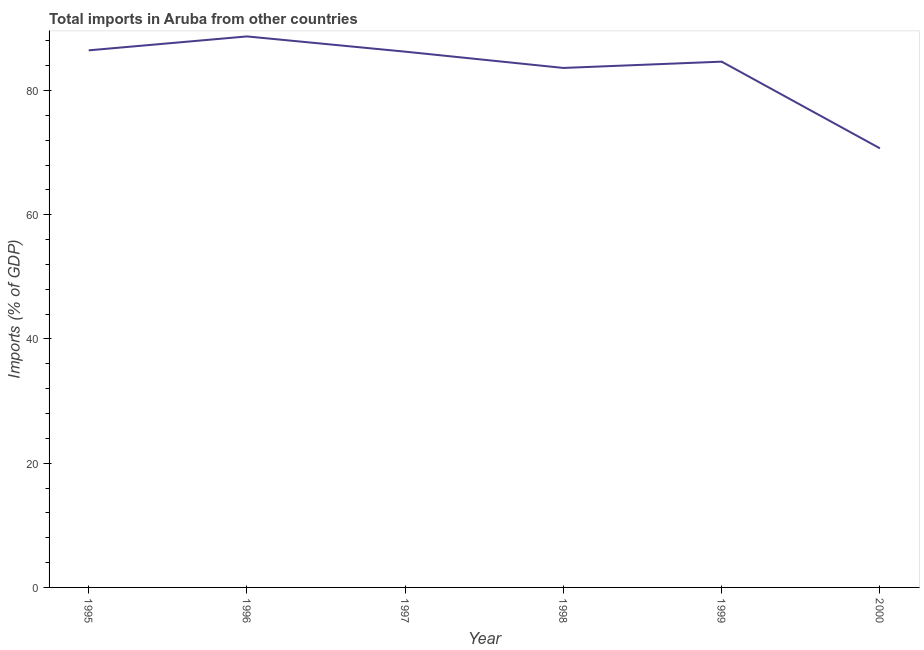What is the total imports in 2000?
Offer a terse response. 70.69. Across all years, what is the maximum total imports?
Offer a very short reply. 88.7. Across all years, what is the minimum total imports?
Your response must be concise. 70.69. In which year was the total imports maximum?
Provide a succinct answer. 1996. In which year was the total imports minimum?
Give a very brief answer. 2000. What is the sum of the total imports?
Provide a short and direct response. 500.38. What is the difference between the total imports in 1995 and 1998?
Offer a terse response. 2.83. What is the average total imports per year?
Ensure brevity in your answer.  83.4. What is the median total imports?
Your response must be concise. 85.45. What is the ratio of the total imports in 1996 to that in 2000?
Ensure brevity in your answer.  1.25. Is the difference between the total imports in 1998 and 1999 greater than the difference between any two years?
Your answer should be compact. No. What is the difference between the highest and the second highest total imports?
Give a very brief answer. 2.24. Is the sum of the total imports in 1997 and 2000 greater than the maximum total imports across all years?
Your answer should be compact. Yes. What is the difference between the highest and the lowest total imports?
Ensure brevity in your answer.  18.02. How many years are there in the graph?
Keep it short and to the point. 6. Does the graph contain grids?
Offer a terse response. No. What is the title of the graph?
Give a very brief answer. Total imports in Aruba from other countries. What is the label or title of the X-axis?
Your answer should be very brief. Year. What is the label or title of the Y-axis?
Make the answer very short. Imports (% of GDP). What is the Imports (% of GDP) of 1995?
Your answer should be compact. 86.46. What is the Imports (% of GDP) in 1996?
Offer a terse response. 88.7. What is the Imports (% of GDP) of 1997?
Ensure brevity in your answer.  86.25. What is the Imports (% of GDP) of 1998?
Your answer should be compact. 83.63. What is the Imports (% of GDP) in 1999?
Offer a terse response. 84.64. What is the Imports (% of GDP) in 2000?
Provide a succinct answer. 70.69. What is the difference between the Imports (% of GDP) in 1995 and 1996?
Ensure brevity in your answer.  -2.24. What is the difference between the Imports (% of GDP) in 1995 and 1997?
Ensure brevity in your answer.  0.21. What is the difference between the Imports (% of GDP) in 1995 and 1998?
Keep it short and to the point. 2.83. What is the difference between the Imports (% of GDP) in 1995 and 1999?
Your answer should be compact. 1.82. What is the difference between the Imports (% of GDP) in 1995 and 2000?
Make the answer very short. 15.78. What is the difference between the Imports (% of GDP) in 1996 and 1997?
Your answer should be compact. 2.45. What is the difference between the Imports (% of GDP) in 1996 and 1998?
Provide a succinct answer. 5.07. What is the difference between the Imports (% of GDP) in 1996 and 1999?
Offer a terse response. 4.06. What is the difference between the Imports (% of GDP) in 1996 and 2000?
Provide a short and direct response. 18.02. What is the difference between the Imports (% of GDP) in 1997 and 1998?
Provide a short and direct response. 2.62. What is the difference between the Imports (% of GDP) in 1997 and 1999?
Offer a very short reply. 1.61. What is the difference between the Imports (% of GDP) in 1997 and 2000?
Keep it short and to the point. 15.56. What is the difference between the Imports (% of GDP) in 1998 and 1999?
Ensure brevity in your answer.  -1.01. What is the difference between the Imports (% of GDP) in 1998 and 2000?
Give a very brief answer. 12.94. What is the difference between the Imports (% of GDP) in 1999 and 2000?
Your answer should be compact. 13.96. What is the ratio of the Imports (% of GDP) in 1995 to that in 1996?
Your answer should be very brief. 0.97. What is the ratio of the Imports (% of GDP) in 1995 to that in 1998?
Keep it short and to the point. 1.03. What is the ratio of the Imports (% of GDP) in 1995 to that in 2000?
Ensure brevity in your answer.  1.22. What is the ratio of the Imports (% of GDP) in 1996 to that in 1997?
Keep it short and to the point. 1.03. What is the ratio of the Imports (% of GDP) in 1996 to that in 1998?
Provide a short and direct response. 1.06. What is the ratio of the Imports (% of GDP) in 1996 to that in 1999?
Your response must be concise. 1.05. What is the ratio of the Imports (% of GDP) in 1996 to that in 2000?
Offer a terse response. 1.25. What is the ratio of the Imports (% of GDP) in 1997 to that in 1998?
Ensure brevity in your answer.  1.03. What is the ratio of the Imports (% of GDP) in 1997 to that in 2000?
Your answer should be compact. 1.22. What is the ratio of the Imports (% of GDP) in 1998 to that in 2000?
Provide a short and direct response. 1.18. What is the ratio of the Imports (% of GDP) in 1999 to that in 2000?
Ensure brevity in your answer.  1.2. 